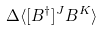<formula> <loc_0><loc_0><loc_500><loc_500>\Delta \langle [ B ^ { \dagger } ] ^ { J } B ^ { K } \rangle</formula> 